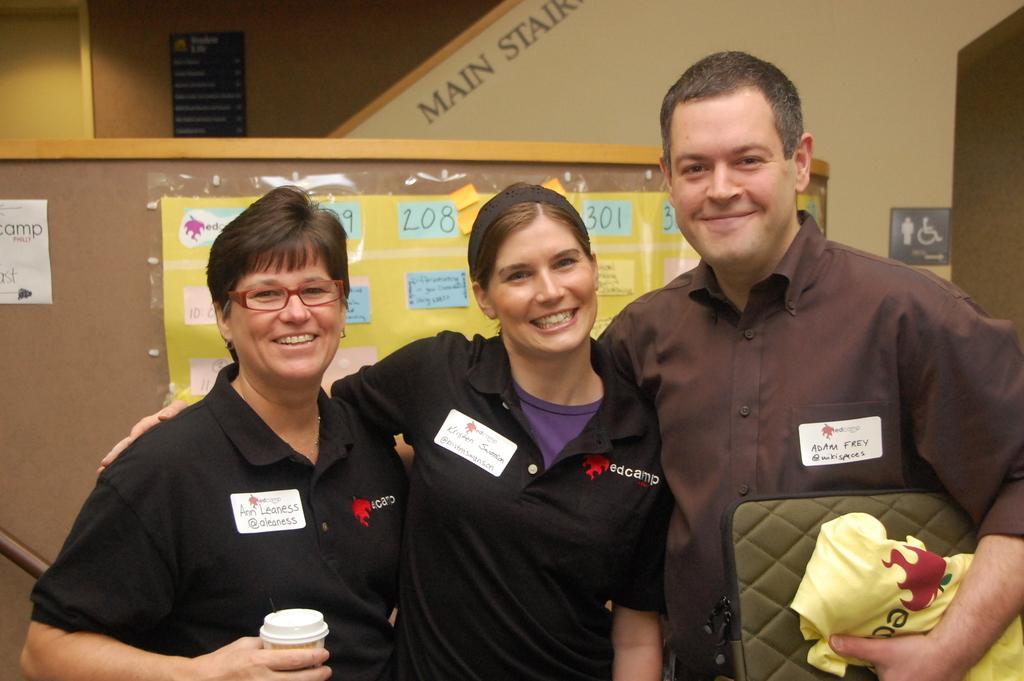Can you describe this image briefly? There are three people in the picture ,first one is an woman holding a coffee cup and a spectacles on her face, second one is a woman with a smile on her face and wearing a hair band to the head,third one is a man with a smile on his face and holding a bag in his hand 